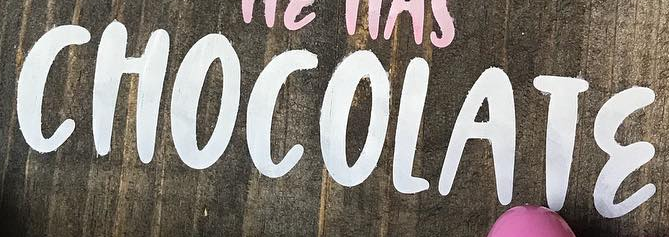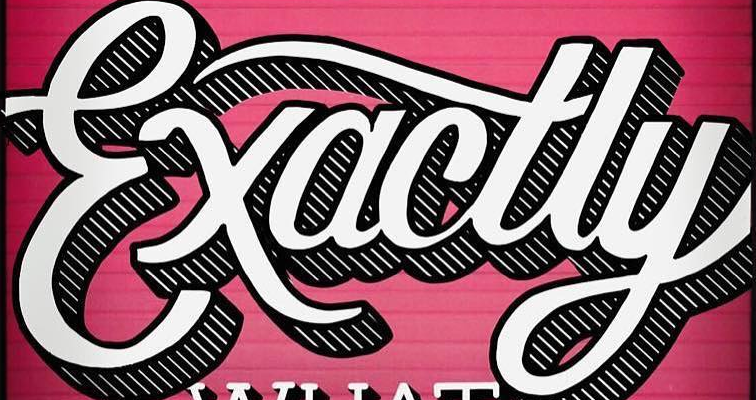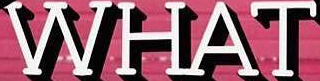What words can you see in these images in sequence, separated by a semicolon? CHOCOLATƐ; Exactly; WHAT 